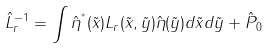Convert formula to latex. <formula><loc_0><loc_0><loc_500><loc_500>\hat { L } _ { r } ^ { - 1 } = \int \hat { \eta } ^ { ^ { * } } ( \tilde { x } ) L _ { r } ( \tilde { x } , \tilde { y } ) \hat { \eta } ( \tilde { y } ) d \tilde { x } d \tilde { y } + \hat { P } _ { 0 }</formula> 